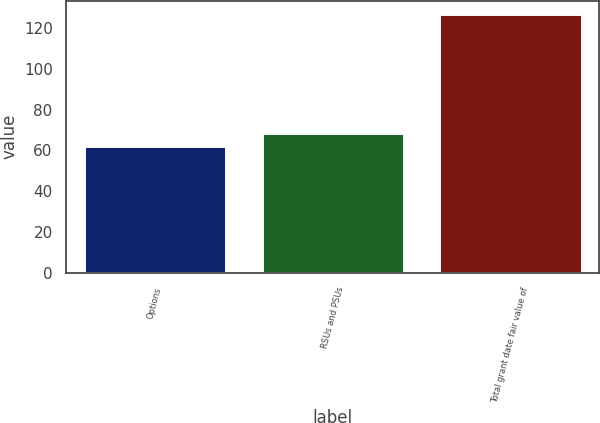Convert chart to OTSL. <chart><loc_0><loc_0><loc_500><loc_500><bar_chart><fcel>Options<fcel>RSUs and PSUs<fcel>Total grant date fair value of<nl><fcel>62<fcel>68.5<fcel>127<nl></chart> 